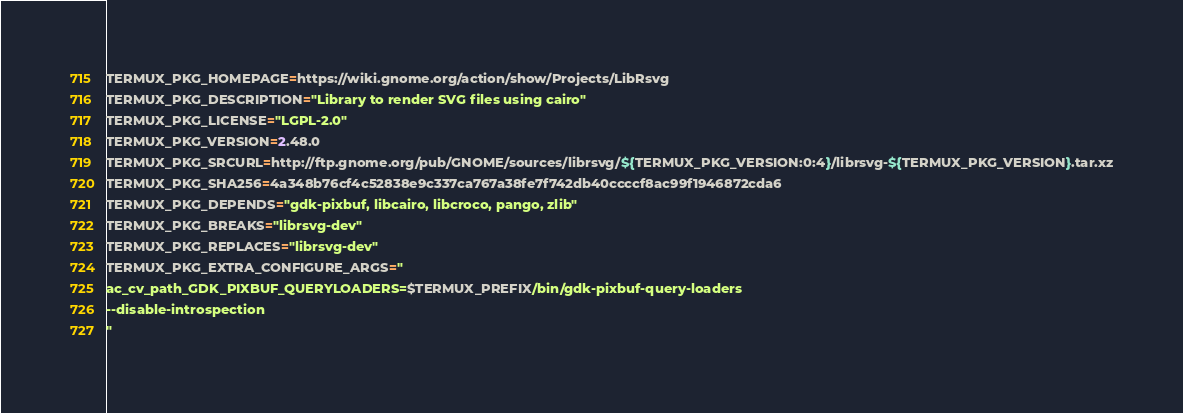<code> <loc_0><loc_0><loc_500><loc_500><_Bash_>TERMUX_PKG_HOMEPAGE=https://wiki.gnome.org/action/show/Projects/LibRsvg
TERMUX_PKG_DESCRIPTION="Library to render SVG files using cairo"
TERMUX_PKG_LICENSE="LGPL-2.0"
TERMUX_PKG_VERSION=2.48.0
TERMUX_PKG_SRCURL=http://ftp.gnome.org/pub/GNOME/sources/librsvg/${TERMUX_PKG_VERSION:0:4}/librsvg-${TERMUX_PKG_VERSION}.tar.xz
TERMUX_PKG_SHA256=4a348b76cf4c52838e9c337ca767a38fe7f742db40ccccf8ac99f1946872cda6
TERMUX_PKG_DEPENDS="gdk-pixbuf, libcairo, libcroco, pango, zlib"
TERMUX_PKG_BREAKS="librsvg-dev"
TERMUX_PKG_REPLACES="librsvg-dev"
TERMUX_PKG_EXTRA_CONFIGURE_ARGS="
ac_cv_path_GDK_PIXBUF_QUERYLOADERS=$TERMUX_PREFIX/bin/gdk-pixbuf-query-loaders
--disable-introspection
"
</code> 